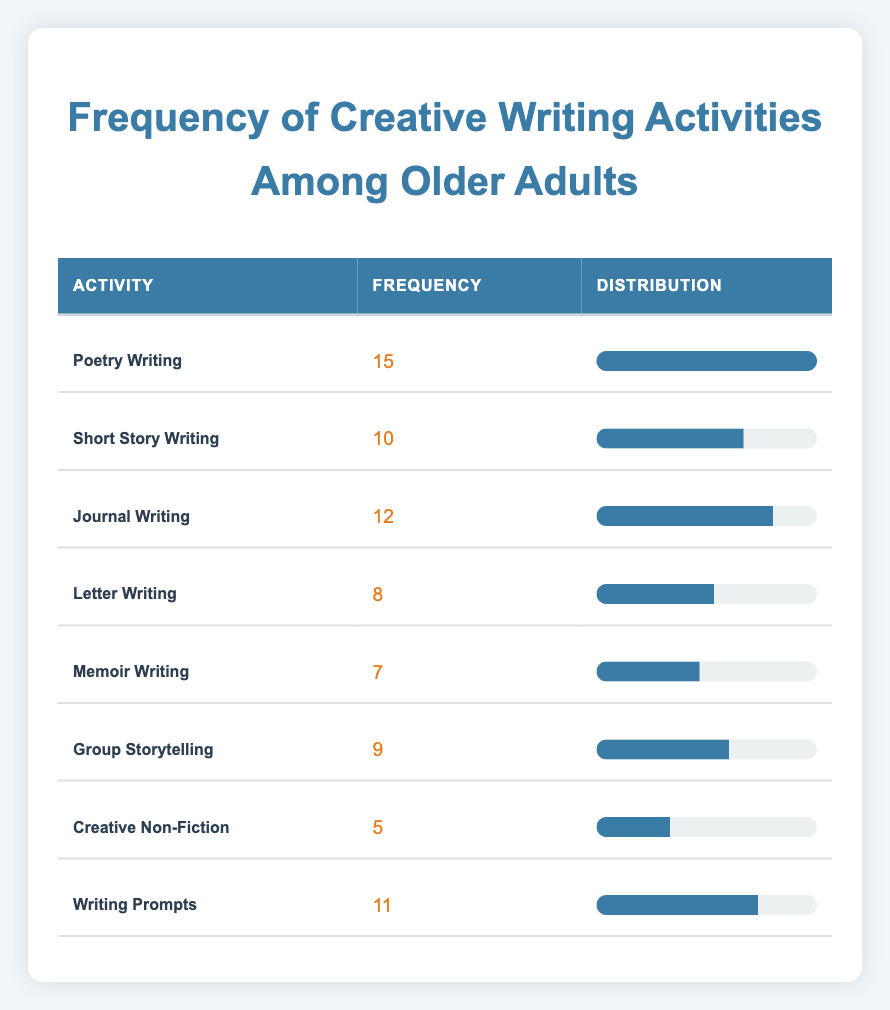What is the most frequent creative writing activity? The table shows that "Poetry Writing" has the highest frequency at 15, more than any other activity listed.
Answer: Poetry Writing How many older adults engaged in Short Story Writing? The table lists a frequency of 10 for "Short Story Writing," indicating that 10 older adults participated in this activity.
Answer: 10 What is the frequency of Letter Writing compared to Memoir Writing? The frequency for "Letter Writing" is 8, while for "Memoir Writing," it is 7. Therefore, Letter Writing has a higher frequency by 1.
Answer: Letter Writing has 1 higher frequency What activities have a frequency of 10 or more? The activities with a frequency of 10 or more are: Poetry Writing (15), Journal Writing (12), Short Story Writing (10), and Writing Prompts (11). There are 4 such activities in total.
Answer: 4 What is the average frequency of the creative writing activities? To find the average, add all frequencies: 15 + 10 + 12 + 8 + 7 + 9 + 5 + 11 = 77. There are 8 activities, so the average is 77/8 = 9.625.
Answer: 9.625 Is Group Storytelling more popular than Creative Non-Fiction? Group Storytelling has a frequency of 9, whereas Creative Non-Fiction has a frequency of 5. Therefore, Group Storytelling is indeed more popular.
Answer: Yes Which activity has the least engagement? The lowest frequency in the table is for "Creative Non-Fiction," which is at 5. This is the least engaged activity among older adults.
Answer: Creative Non-Fiction If we combine the frequencies of Journal Writing and Writing Prompts, what is the total? The frequencies are 12 for Journal Writing and 11 for Writing Prompts. When combined, the total is 12 + 11 = 23.
Answer: 23 